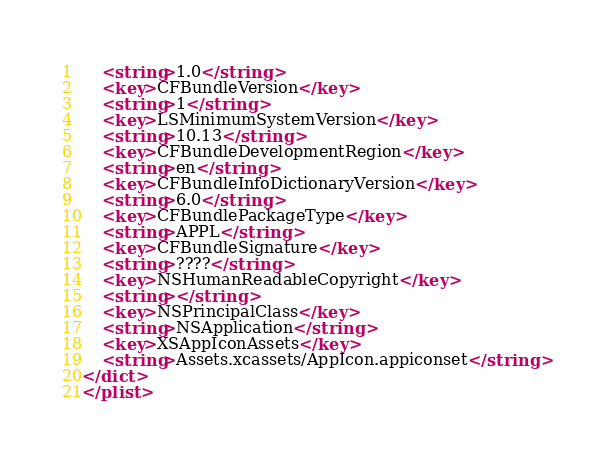Convert code to text. <code><loc_0><loc_0><loc_500><loc_500><_XML_>	<string>1.0</string>
	<key>CFBundleVersion</key>
	<string>1</string>
	<key>LSMinimumSystemVersion</key>
	<string>10.13</string>
	<key>CFBundleDevelopmentRegion</key>
	<string>en</string>
	<key>CFBundleInfoDictionaryVersion</key>
	<string>6.0</string>
	<key>CFBundlePackageType</key>
	<string>APPL</string>
	<key>CFBundleSignature</key>
	<string>????</string>
	<key>NSHumanReadableCopyright</key>
	<string></string>
	<key>NSPrincipalClass</key>
	<string>NSApplication</string>
	<key>XSAppIconAssets</key>
	<string>Assets.xcassets/AppIcon.appiconset</string>
</dict>
</plist>
</code> 